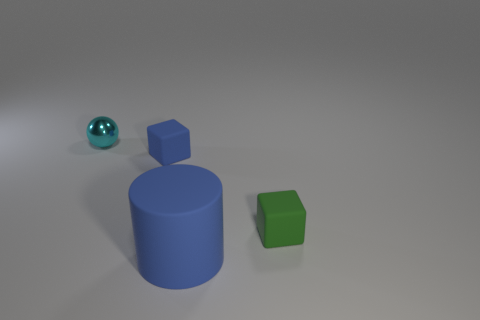Add 4 blue things. How many objects exist? 8 Subtract all balls. How many objects are left? 3 Subtract 0 yellow cylinders. How many objects are left? 4 Subtract all green blocks. Subtract all green blocks. How many objects are left? 2 Add 2 big matte objects. How many big matte objects are left? 3 Add 4 small cyan shiny things. How many small cyan shiny things exist? 5 